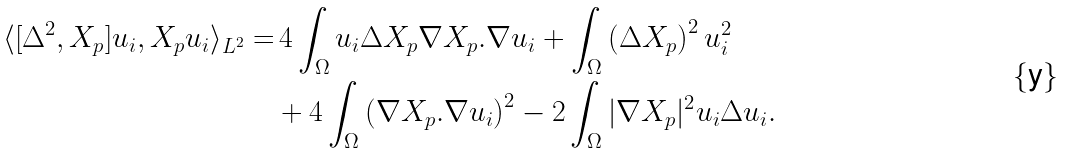Convert formula to latex. <formula><loc_0><loc_0><loc_500><loc_500>\langle [ \Delta ^ { 2 } , X _ { p } ] u _ { i } , X _ { p } u _ { i } \rangle _ { L ^ { 2 } } = & \, 4 \int _ { \Omega } u _ { i } \Delta X _ { p } \nabla X _ { p } . \nabla u _ { i } + \int _ { \Omega } \left ( \Delta X _ { p } \right ) ^ { 2 } u _ { i } ^ { 2 } \\ & + 4 \int _ { \Omega } \left ( \nabla X _ { p } . \nabla u _ { i } \right ) ^ { 2 } - 2 \int _ { \Omega } | \nabla X _ { p } | ^ { 2 } u _ { i } \Delta u _ { i } .</formula> 